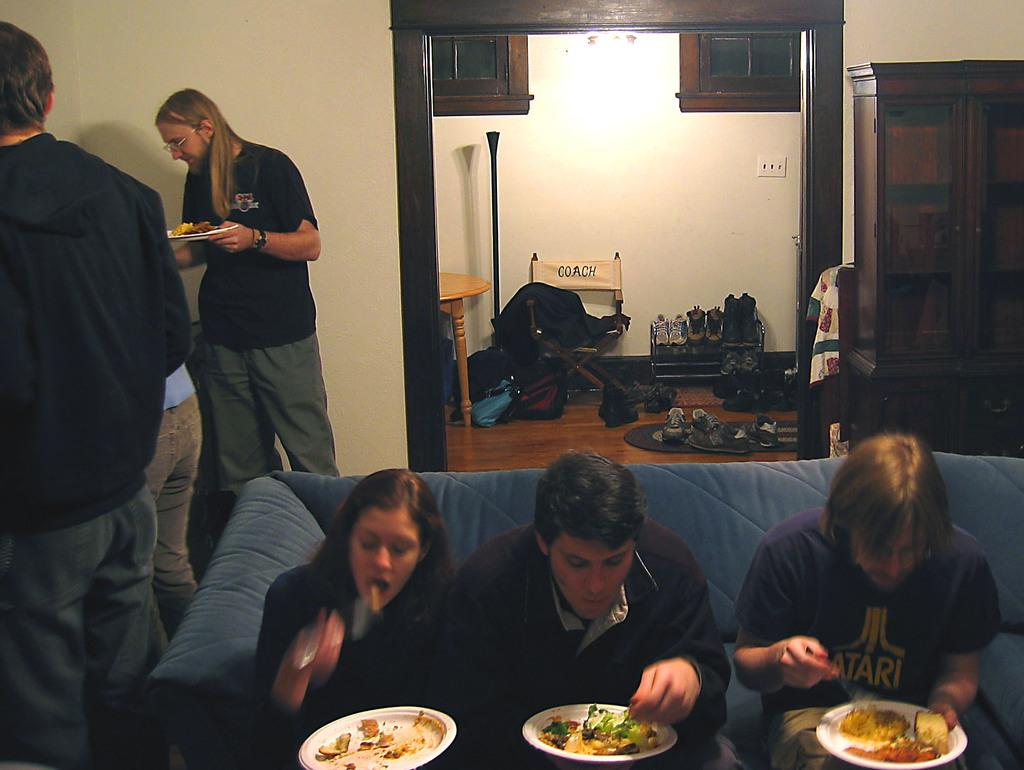How many people are sitting on the sofa in the image? There are three persons sitting on the sofa in the image. What are the people on the sofa doing? The persons on the sofa are eating. Are there any other people visible in the image? Yes, there are people beside the sofa. What can be seen in the background of the image? There is a group of shoes in the background. What type of heat source is being used to cook the food in the image? There is no heat source or cooking activity visible in the image; the people are simply eating. 